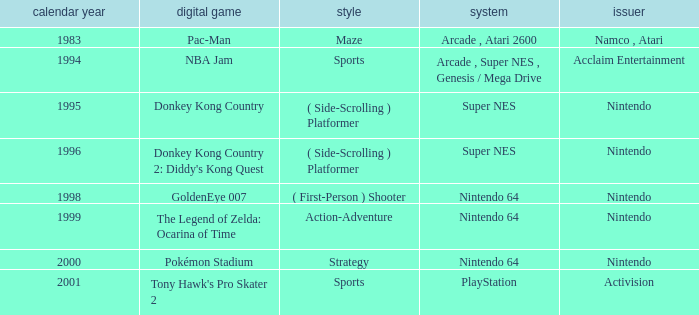Which Genre has a Game of donkey kong country? ( Side-Scrolling ) Platformer. 